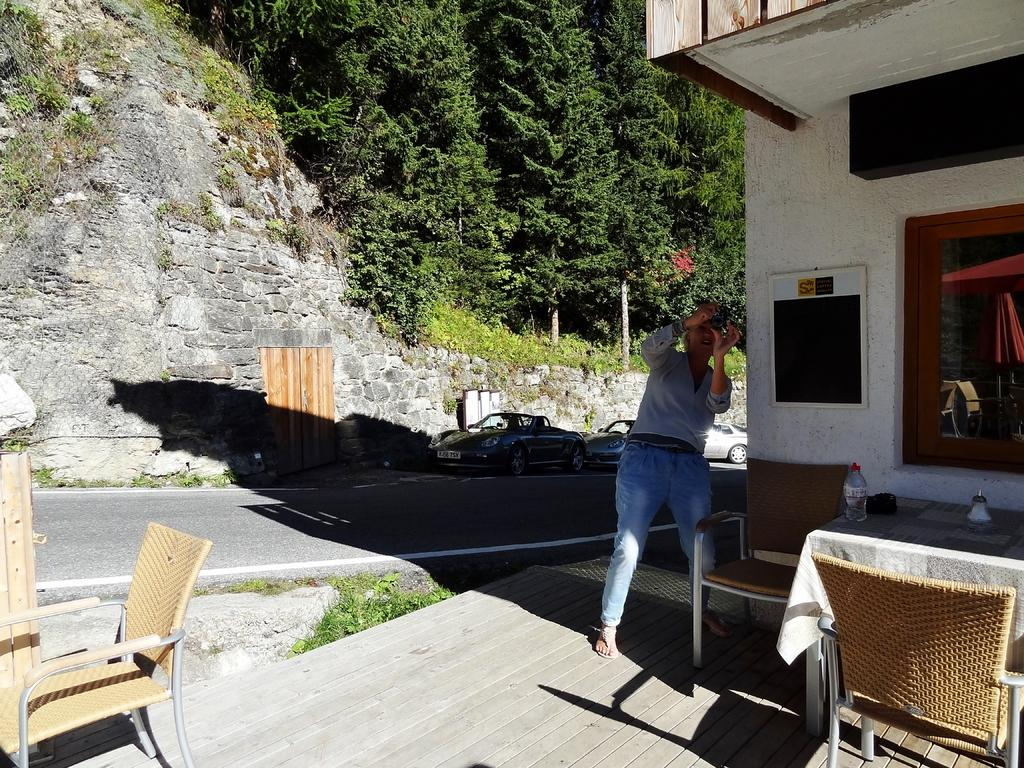What object is on the table in the image? There is a bottle on the table in the image. What is the man in the image doing? The man is taking a picture with a camera in the image. What can be seen in the background of the image? There is a building visible in the image. What type of vehicles are present in the image? There are cars in the image. What type of vegetation is visible in the image? There are trees in the image. Can you see any branches in the image? There is no mention of branches in the provided facts, and therefore we cannot determine if any are present in the image. What type of apparatus is the man using to blow up the balloons in the image? There is no mention of balloons or any apparatus for blowing in the provided facts, and therefore we cannot determine if any are present in the image. 